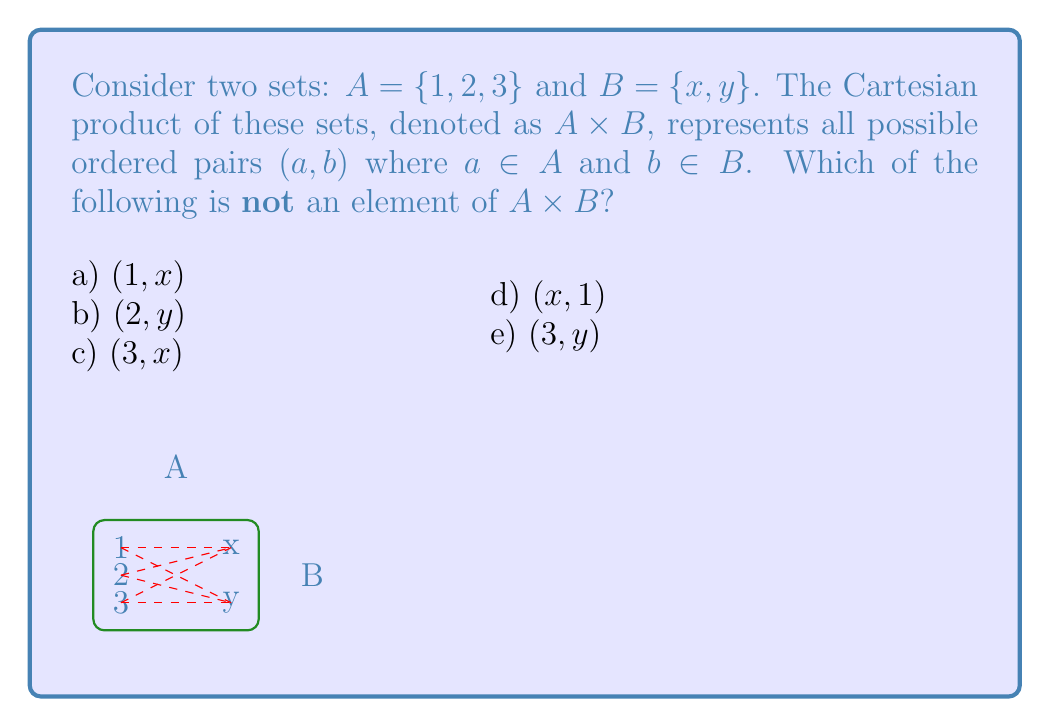Teach me how to tackle this problem. Let's approach this step-by-step:

1) First, we need to understand what the Cartesian product $A \times B$ means. It's the set of all ordered pairs $(a, b)$ where $a$ is from set $A$ and $b$ is from set $B$.

2) Set $A$ has 3 elements: $\{1, 2, 3\}$
   Set $B$ has 2 elements: $\{x, y\}$

3) To form the Cartesian product, we pair each element from $A$ with each element from $B$. This gives us:

   $A \times B = \{(1,x), (1,y), (2,x), (2,y), (3,x), (3,y)\}$

4) Now, let's check each option:

   a) $(1, x)$ is in $A \times B$
   b) $(2, y)$ is in $A \times B$
   c) $(3, x)$ is in $A \times B$
   d) $(x, 1)$ is not in $A \times B$ because the first element should be from $A$ and the second from $B$, not vice versa.
   e) $(3, y)$ is in $A \times B$

5) Therefore, the option that is not an element of $A \times B$ is $(x, 1)$.

The diagram in the question visually represents this Cartesian product, with dashed lines connecting elements from set $A$ to elements from set $B$ to form the ordered pairs.
Answer: d) $(x, 1)$ 